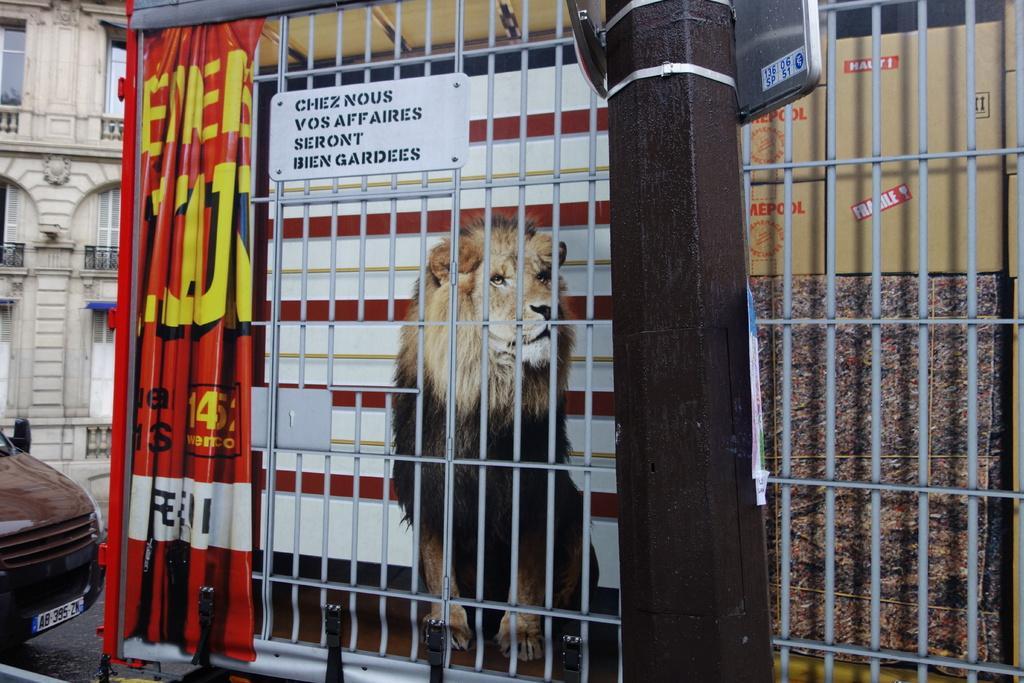Describe this image in one or two sentences. In this picture we can see a lion, board, banner, pole, carton box, and grill. There is a vehicle on the road and this is building. 